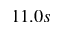Convert formula to latex. <formula><loc_0><loc_0><loc_500><loc_500>1 1 . 0 s</formula> 